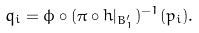Convert formula to latex. <formula><loc_0><loc_0><loc_500><loc_500>q _ { i } = \phi \circ ( \pi \circ h | _ { B _ { 1 } ^ { \prime } } ) ^ { - 1 } ( p _ { i } ) .</formula> 